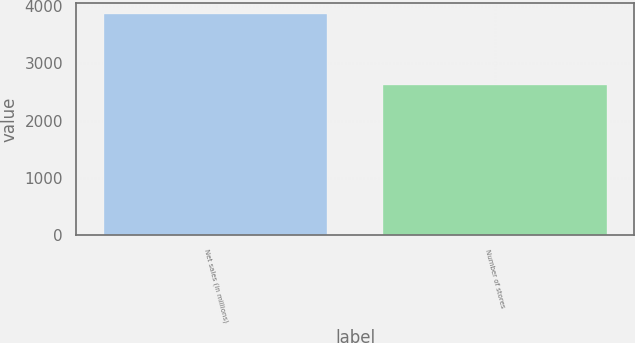Convert chart. <chart><loc_0><loc_0><loc_500><loc_500><bar_chart><fcel>Net sales (in millions)<fcel>Number of stores<nl><fcel>3869.2<fcel>2622<nl></chart> 